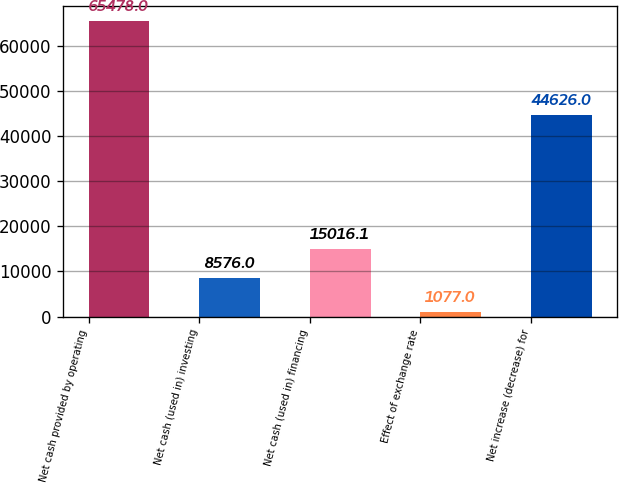<chart> <loc_0><loc_0><loc_500><loc_500><bar_chart><fcel>Net cash provided by operating<fcel>Net cash (used in) investing<fcel>Net cash (used in) financing<fcel>Effect of exchange rate<fcel>Net increase (decrease) for<nl><fcel>65478<fcel>8576<fcel>15016.1<fcel>1077<fcel>44626<nl></chart> 